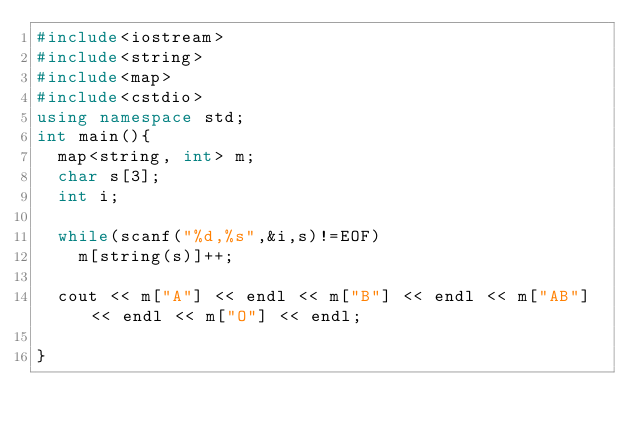<code> <loc_0><loc_0><loc_500><loc_500><_C++_>#include<iostream>
#include<string>
#include<map>
#include<cstdio>
using namespace std;
int main(){
  map<string, int> m;
  char s[3];
  int i;

  while(scanf("%d,%s",&i,s)!=EOF)
    m[string(s)]++;

  cout << m["A"] << endl << m["B"] << endl << m["AB"] << endl << m["O"] << endl;

}</code> 